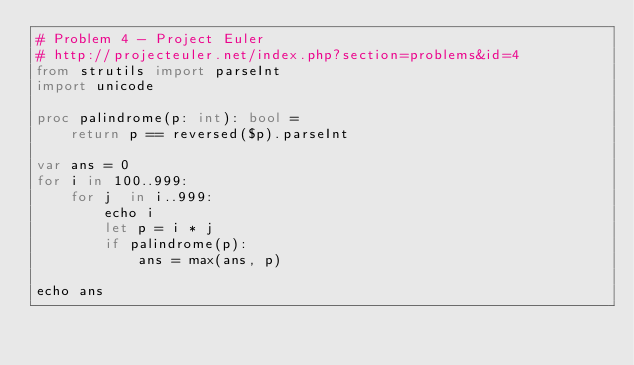Convert code to text. <code><loc_0><loc_0><loc_500><loc_500><_Nim_># Problem 4 - Project Euler
# http://projecteuler.net/index.php?section=problems&id=4
from strutils import parseInt
import unicode

proc palindrome(p: int): bool =
    return p == reversed($p).parseInt

var ans = 0
for i in 100..999:
    for j  in i..999:
        echo i
        let p = i * j
        if palindrome(p):
            ans = max(ans, p)

echo ans
</code> 